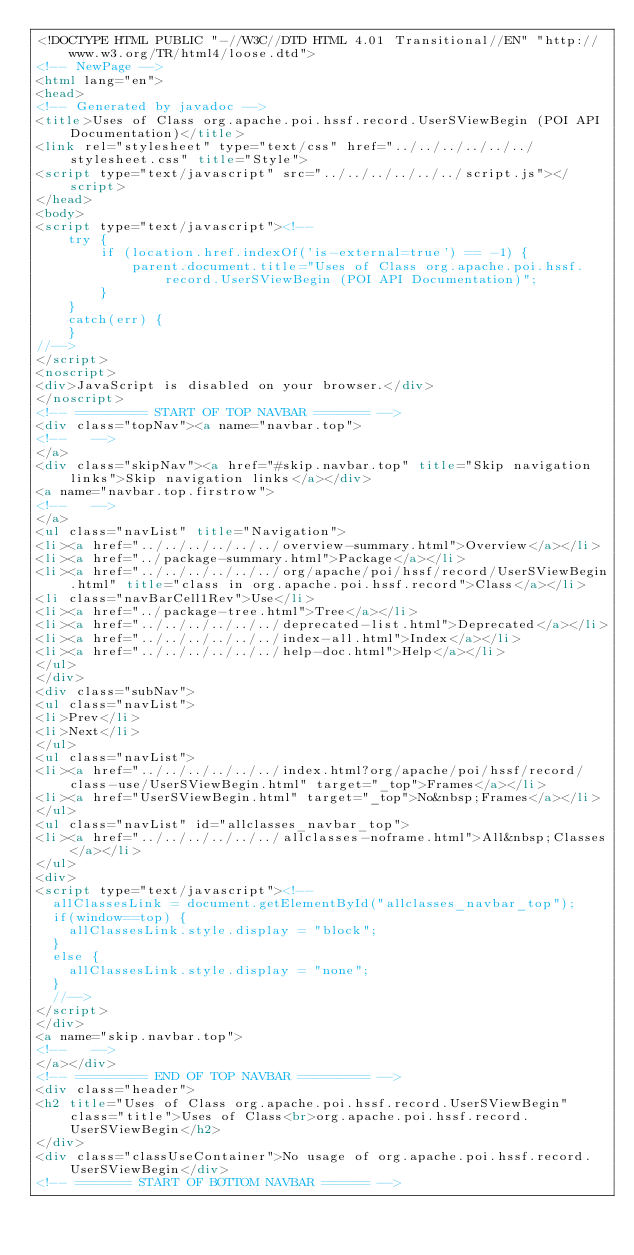<code> <loc_0><loc_0><loc_500><loc_500><_HTML_><!DOCTYPE HTML PUBLIC "-//W3C//DTD HTML 4.01 Transitional//EN" "http://www.w3.org/TR/html4/loose.dtd">
<!-- NewPage -->
<html lang="en">
<head>
<!-- Generated by javadoc -->
<title>Uses of Class org.apache.poi.hssf.record.UserSViewBegin (POI API Documentation)</title>
<link rel="stylesheet" type="text/css" href="../../../../../../stylesheet.css" title="Style">
<script type="text/javascript" src="../../../../../../script.js"></script>
</head>
<body>
<script type="text/javascript"><!--
    try {
        if (location.href.indexOf('is-external=true') == -1) {
            parent.document.title="Uses of Class org.apache.poi.hssf.record.UserSViewBegin (POI API Documentation)";
        }
    }
    catch(err) {
    }
//-->
</script>
<noscript>
<div>JavaScript is disabled on your browser.</div>
</noscript>
<!-- ========= START OF TOP NAVBAR ======= -->
<div class="topNav"><a name="navbar.top">
<!--   -->
</a>
<div class="skipNav"><a href="#skip.navbar.top" title="Skip navigation links">Skip navigation links</a></div>
<a name="navbar.top.firstrow">
<!--   -->
</a>
<ul class="navList" title="Navigation">
<li><a href="../../../../../../overview-summary.html">Overview</a></li>
<li><a href="../package-summary.html">Package</a></li>
<li><a href="../../../../../../org/apache/poi/hssf/record/UserSViewBegin.html" title="class in org.apache.poi.hssf.record">Class</a></li>
<li class="navBarCell1Rev">Use</li>
<li><a href="../package-tree.html">Tree</a></li>
<li><a href="../../../../../../deprecated-list.html">Deprecated</a></li>
<li><a href="../../../../../../index-all.html">Index</a></li>
<li><a href="../../../../../../help-doc.html">Help</a></li>
</ul>
</div>
<div class="subNav">
<ul class="navList">
<li>Prev</li>
<li>Next</li>
</ul>
<ul class="navList">
<li><a href="../../../../../../index.html?org/apache/poi/hssf/record/class-use/UserSViewBegin.html" target="_top">Frames</a></li>
<li><a href="UserSViewBegin.html" target="_top">No&nbsp;Frames</a></li>
</ul>
<ul class="navList" id="allclasses_navbar_top">
<li><a href="../../../../../../allclasses-noframe.html">All&nbsp;Classes</a></li>
</ul>
<div>
<script type="text/javascript"><!--
  allClassesLink = document.getElementById("allclasses_navbar_top");
  if(window==top) {
    allClassesLink.style.display = "block";
  }
  else {
    allClassesLink.style.display = "none";
  }
  //-->
</script>
</div>
<a name="skip.navbar.top">
<!--   -->
</a></div>
<!-- ========= END OF TOP NAVBAR ========= -->
<div class="header">
<h2 title="Uses of Class org.apache.poi.hssf.record.UserSViewBegin" class="title">Uses of Class<br>org.apache.poi.hssf.record.UserSViewBegin</h2>
</div>
<div class="classUseContainer">No usage of org.apache.poi.hssf.record.UserSViewBegin</div>
<!-- ======= START OF BOTTOM NAVBAR ====== --></code> 